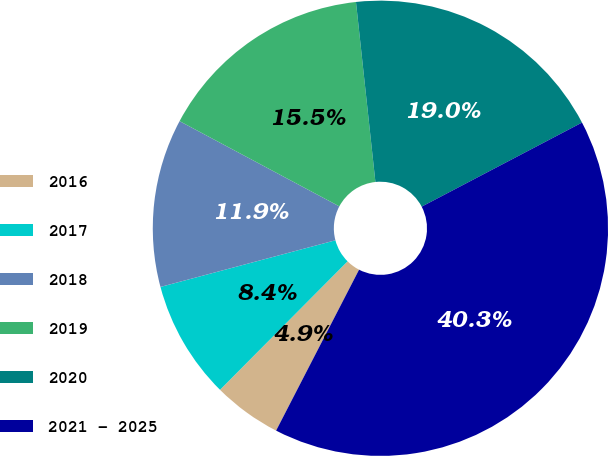Convert chart to OTSL. <chart><loc_0><loc_0><loc_500><loc_500><pie_chart><fcel>2016<fcel>2017<fcel>2018<fcel>2019<fcel>2020<fcel>2021 - 2025<nl><fcel>4.87%<fcel>8.41%<fcel>11.95%<fcel>15.49%<fcel>19.03%<fcel>40.27%<nl></chart> 